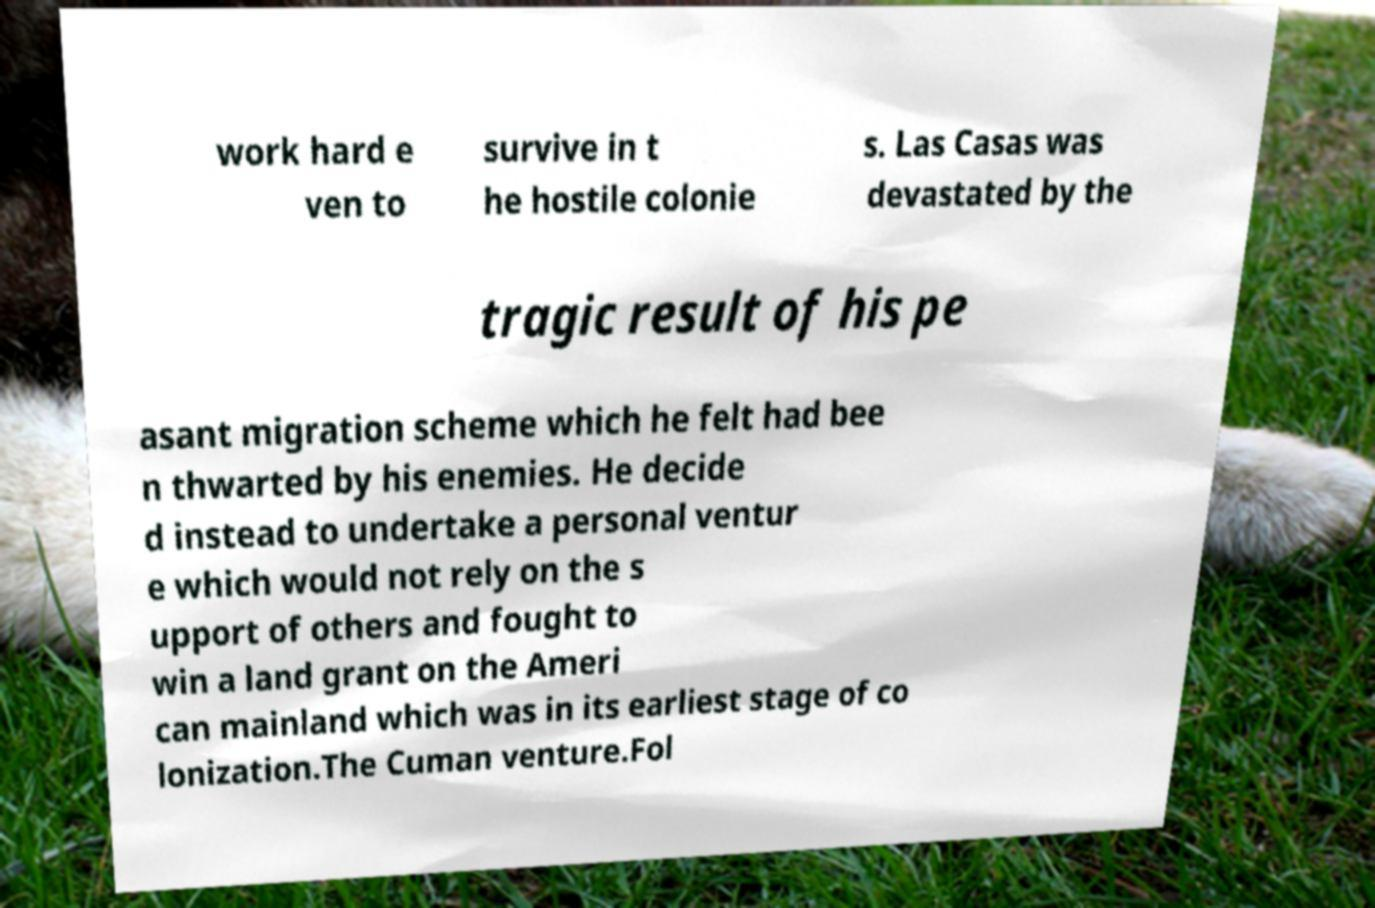I need the written content from this picture converted into text. Can you do that? work hard e ven to survive in t he hostile colonie s. Las Casas was devastated by the tragic result of his pe asant migration scheme which he felt had bee n thwarted by his enemies. He decide d instead to undertake a personal ventur e which would not rely on the s upport of others and fought to win a land grant on the Ameri can mainland which was in its earliest stage of co lonization.The Cuman venture.Fol 